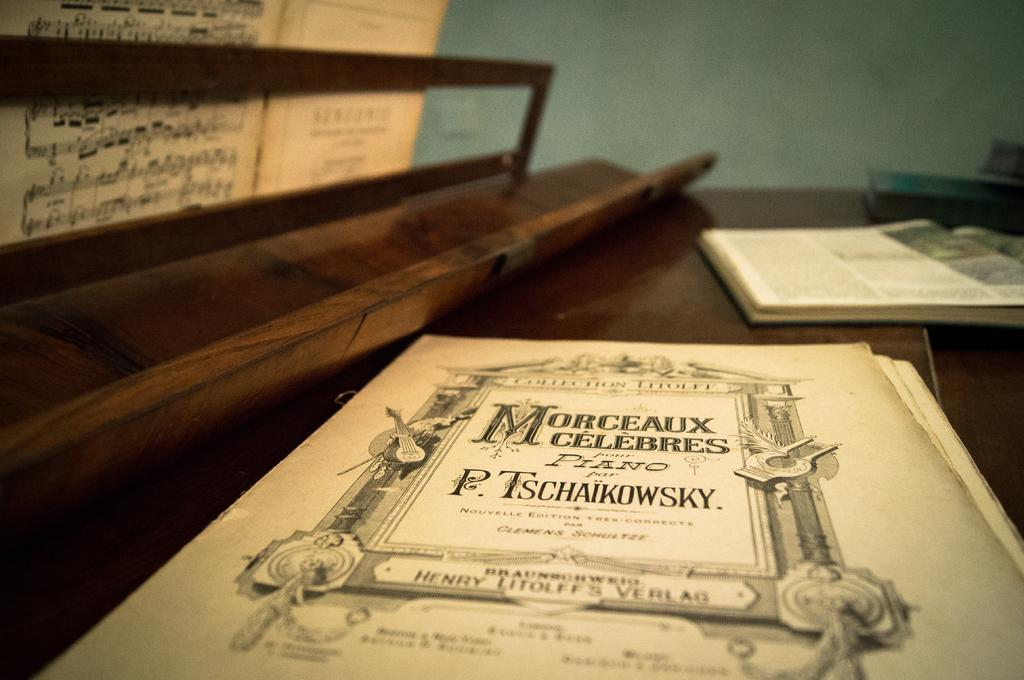Provide a one-sentence caption for the provided image. a P. TSCHAIKOWSKY piano music book entitled MORCEAUX CELEBRES. 